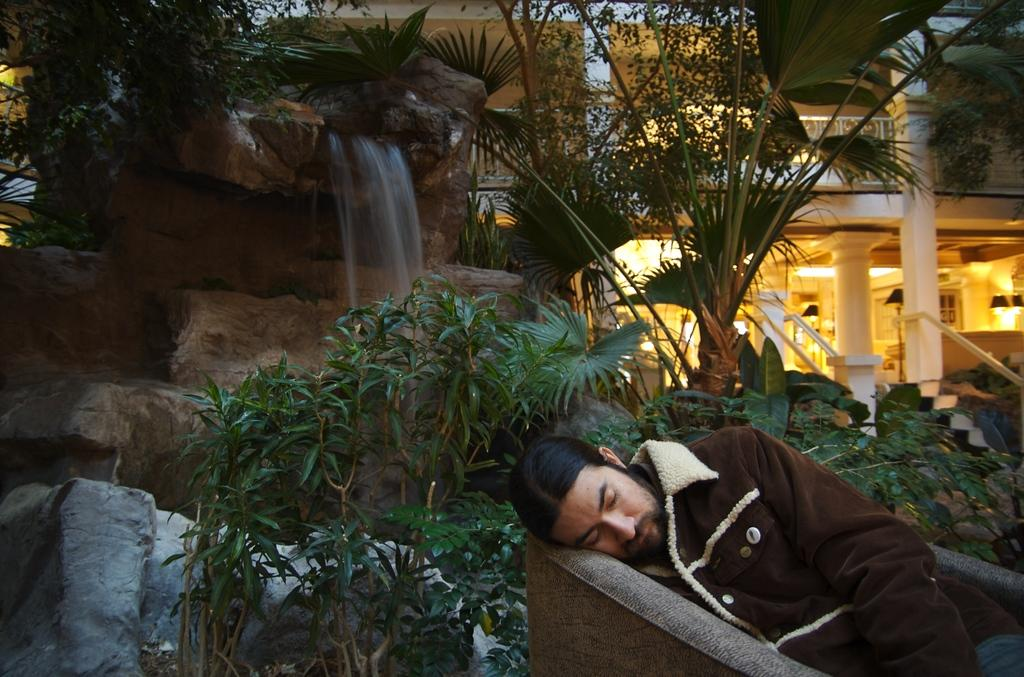What type of natural elements can be seen in the image? There are plants and trees visible in the image. What is the water feature in the image? There is water visible in the image. What type of geological formations are present in the image? There are rocks in the image. What type of man-made structures can be seen in the image? There are buildings in the image. Can you describe the man's position in the image? There is a man sleeping on a sofa in the front of the image. What type of fowl can be seen interacting with the man on the sofa in the image? There is no fowl present in the image; the man is sleeping on a sofa by himself. What type of acoustics can be heard in the image? There is no information about sounds or acoustics in the image, as it only provides visual information. 